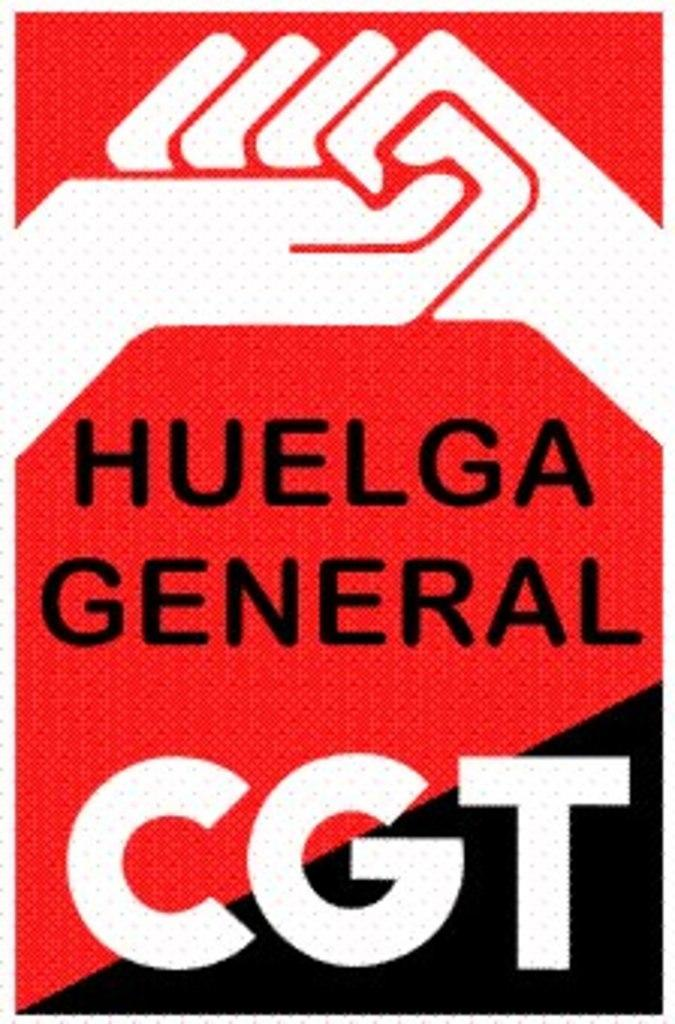<image>
Give a short and clear explanation of the subsequent image. a poster that says 'huelga general cgt' with black and red and white on it 